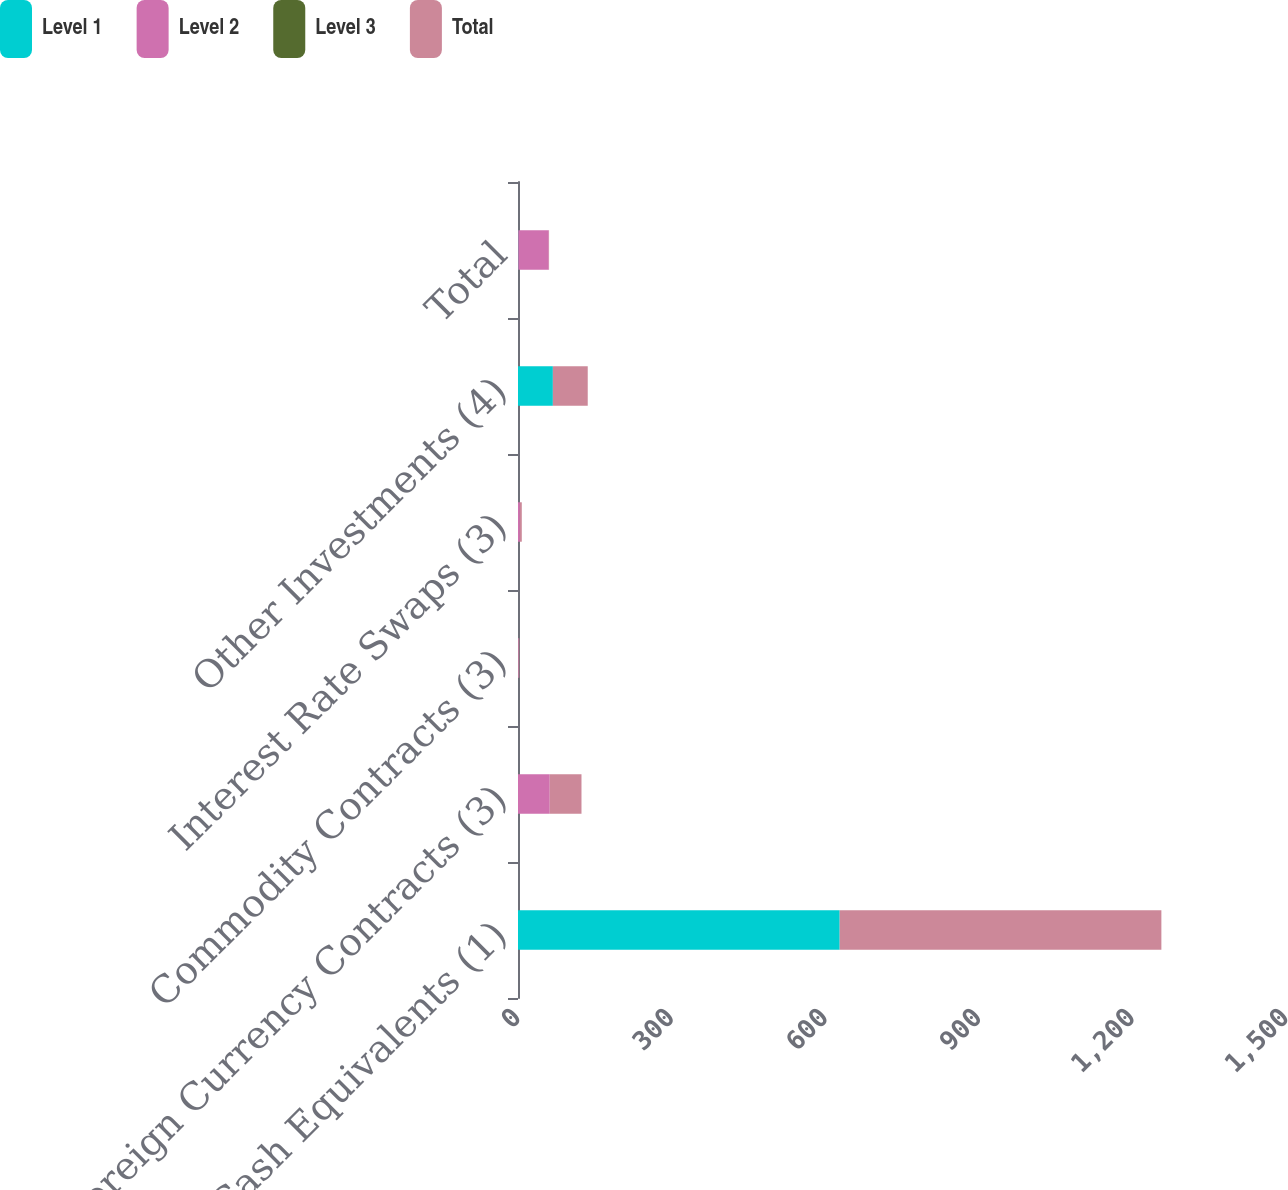<chart> <loc_0><loc_0><loc_500><loc_500><stacked_bar_chart><ecel><fcel>Cash Equivalents (1)<fcel>Foreign Currency Contracts (3)<fcel>Commodity Contracts (3)<fcel>Interest Rate Swaps (3)<fcel>Other Investments (4)<fcel>Total<nl><fcel>Level 1<fcel>628.3<fcel>0<fcel>0<fcel>0<fcel>68.1<fcel>0.6<nl><fcel>Level 2<fcel>0<fcel>62<fcel>1.2<fcel>3.7<fcel>0<fcel>59.5<nl><fcel>Level 3<fcel>0<fcel>0<fcel>0<fcel>0<fcel>0<fcel>0<nl><fcel>Total<fcel>628.3<fcel>62<fcel>1.2<fcel>3.7<fcel>68.1<fcel>0.6<nl></chart> 